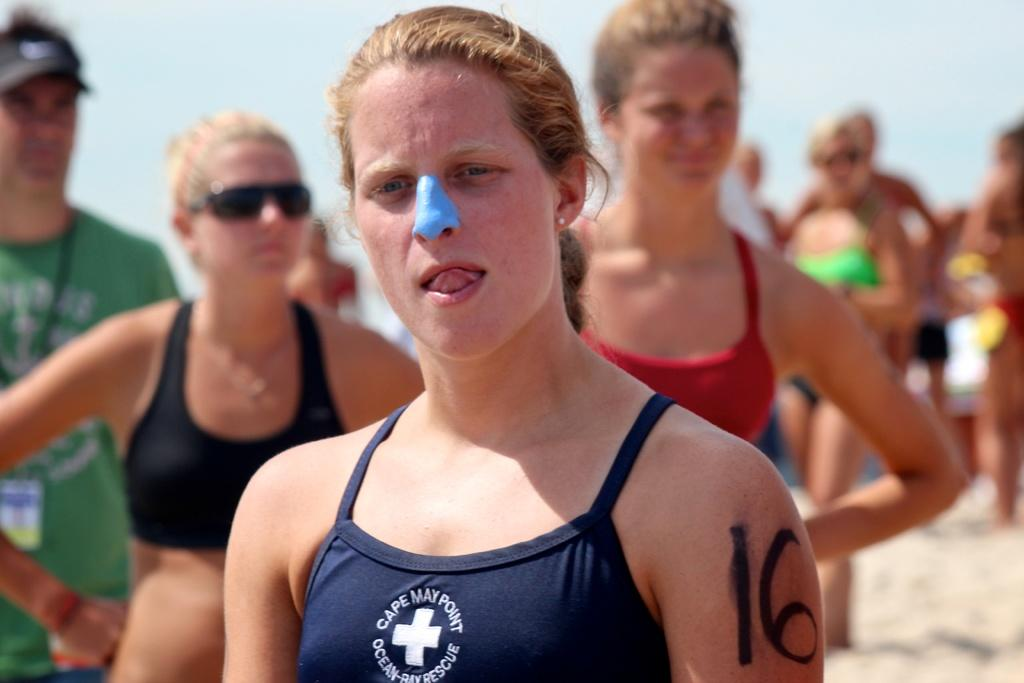<image>
Create a compact narrative representing the image presented. a woman wearing a Cape May Point swim suit stands on a beach with others 